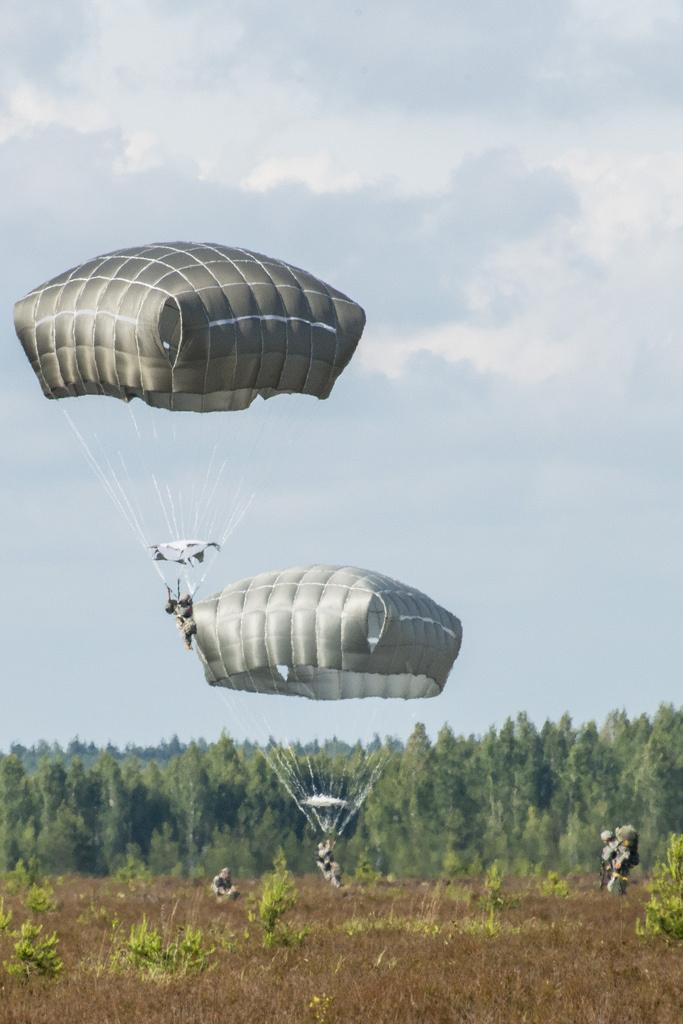What can be seen in the sky in the image? The sky is visible in the background of the image. What are the people on the parachutes doing? The people on the parachutes are parachuting. What type of vegetation is in the background of the image? There are trees in the background of the image. What is on the ground in the image? There is grass on the ground in the image. What else can be seen on the ground in the image? There are people on the ground in the image. What book is the person on the parachute reading in the image? There is no book or reading activity depicted in the image. How many legs does the tree in the background have? The image does not provide information about the number of legs on the tree, as trees do not have legs. 